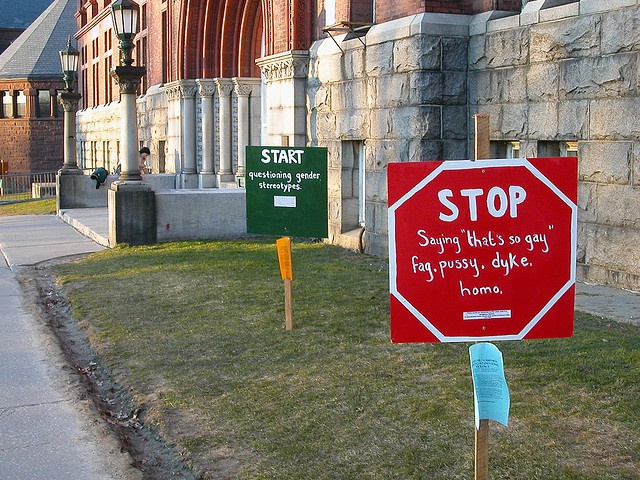Describe the objects in this image and their specific colors. I can see stop sign in blue, brown, lavender, lightblue, and maroon tones, people in blue, black, gray, teal, and darkblue tones, and people in blue, black, gray, and darkgray tones in this image. 